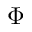<formula> <loc_0><loc_0><loc_500><loc_500>\Phi</formula> 